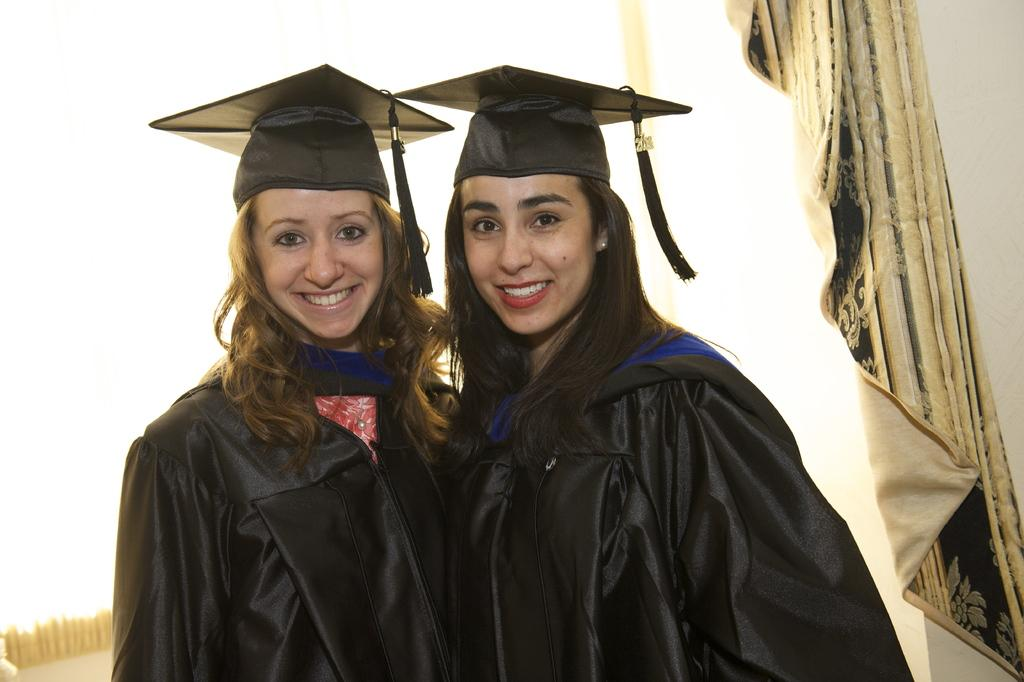How many women are in the image? There are two women in the center of the image. What are the women wearing? Both women are wearing black coats and black hats. What can be seen towards the right side of the image? There is a curtain towards the right side of the image. What is the name of the son of the woman on the left side of the image? There is no son or name mentioned in the image; it only features two women wearing black coats and hats. Can you see a snake in the image? No, there is no snake present in the image. 